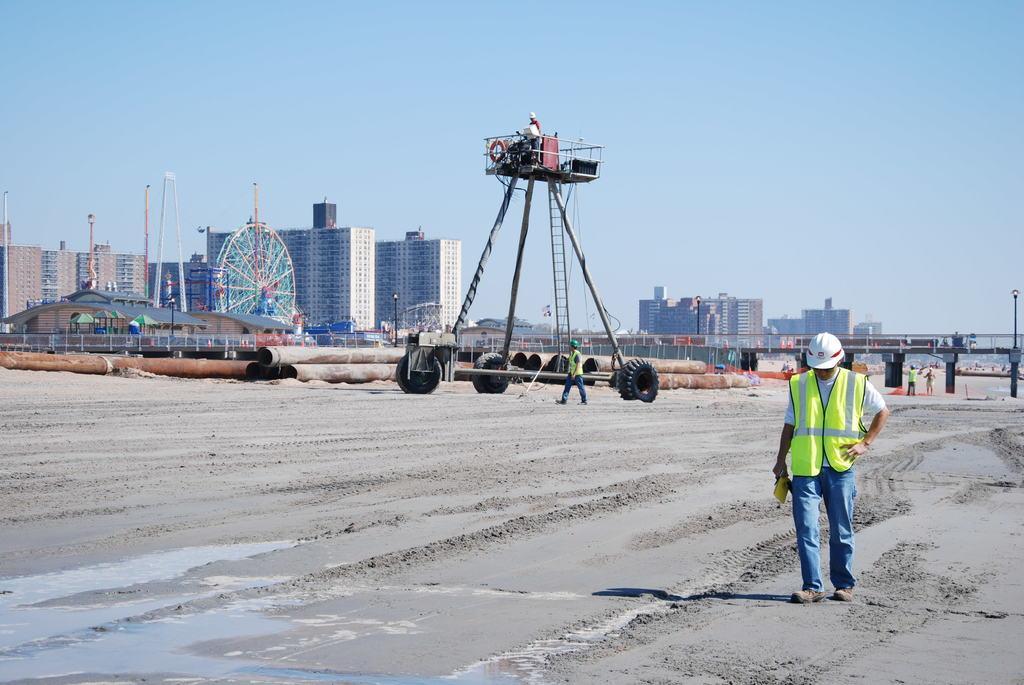Describe this image in one or two sentences. In this image I can see there are persons on the ground. And there is a crane and a pipeline. And there is a giant wheel, rod, light pole and a fence. And at the back there are buildings. And there is a bridge. And at the top there is a sky. 